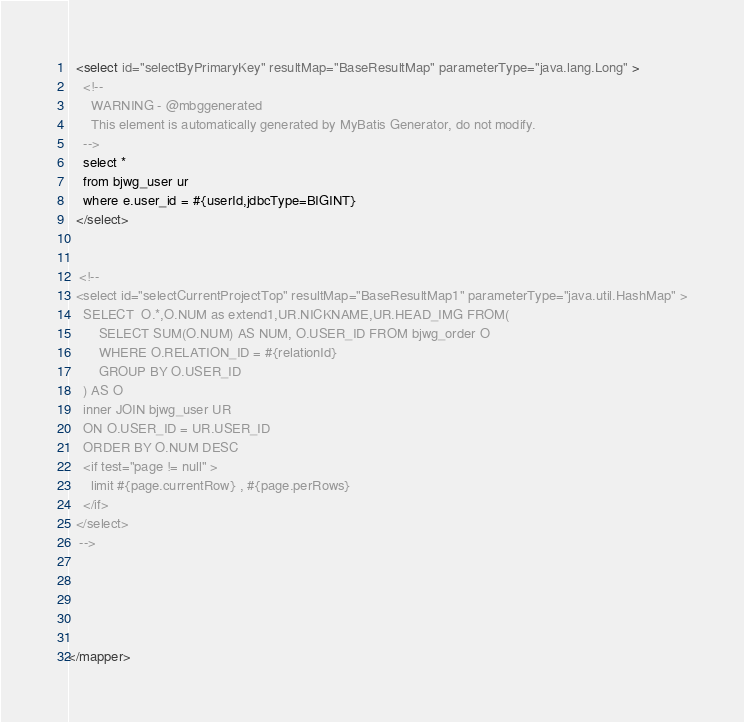<code> <loc_0><loc_0><loc_500><loc_500><_XML_>  <select id="selectByPrimaryKey" resultMap="BaseResultMap" parameterType="java.lang.Long" >
    <!--
      WARNING - @mbggenerated
      This element is automatically generated by MyBatis Generator, do not modify.
    -->
    select *
    from bjwg_user ur
    where e.user_id = #{userId,jdbcType=BIGINT}
  </select>
  
  
   <!--  
  <select id="selectCurrentProjectTop" resultMap="BaseResultMap1" parameterType="java.util.HashMap" >
    SELECT  O.*,O.NUM as extend1,UR.NICKNAME,UR.HEAD_IMG FROM(
		SELECT SUM(O.NUM) AS NUM, O.USER_ID FROM bjwg_order O
		WHERE O.RELATION_ID = #{relationId}
		GROUP BY O.USER_ID
	) AS O
	inner JOIN bjwg_user UR
	ON O.USER_ID = UR.USER_ID
	ORDER BY O.NUM DESC
    <if test="page != null" >
      limit #{page.currentRow} , #{page.perRows}
    </if>
  </select>
   -->
  
  
 

  
</mapper></code> 